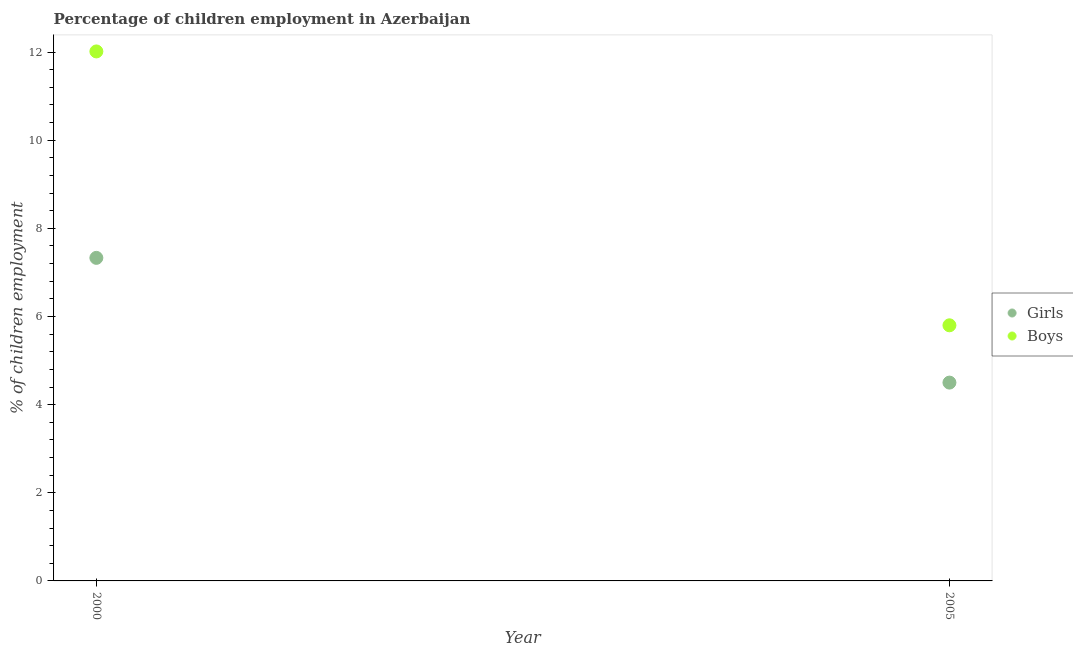What is the percentage of employed boys in 2005?
Ensure brevity in your answer.  5.8. Across all years, what is the maximum percentage of employed boys?
Your answer should be compact. 12.01. Across all years, what is the minimum percentage of employed boys?
Provide a succinct answer. 5.8. What is the total percentage of employed girls in the graph?
Keep it short and to the point. 11.83. What is the difference between the percentage of employed boys in 2000 and that in 2005?
Make the answer very short. 6.21. What is the difference between the percentage of employed boys in 2000 and the percentage of employed girls in 2005?
Provide a short and direct response. 7.51. What is the average percentage of employed boys per year?
Your answer should be very brief. 8.91. In the year 2000, what is the difference between the percentage of employed boys and percentage of employed girls?
Provide a succinct answer. 4.68. In how many years, is the percentage of employed girls greater than 1.6 %?
Offer a very short reply. 2. What is the ratio of the percentage of employed girls in 2000 to that in 2005?
Make the answer very short. 1.63. Is the percentage of employed boys in 2000 less than that in 2005?
Make the answer very short. No. In how many years, is the percentage of employed girls greater than the average percentage of employed girls taken over all years?
Give a very brief answer. 1. Does the percentage of employed girls monotonically increase over the years?
Offer a very short reply. No. Is the percentage of employed boys strictly greater than the percentage of employed girls over the years?
Give a very brief answer. Yes. How many dotlines are there?
Make the answer very short. 2. How many years are there in the graph?
Provide a succinct answer. 2. What is the difference between two consecutive major ticks on the Y-axis?
Your answer should be compact. 2. Does the graph contain any zero values?
Offer a terse response. No. Where does the legend appear in the graph?
Ensure brevity in your answer.  Center right. How many legend labels are there?
Provide a succinct answer. 2. How are the legend labels stacked?
Offer a very short reply. Vertical. What is the title of the graph?
Ensure brevity in your answer.  Percentage of children employment in Azerbaijan. Does "Urban Population" appear as one of the legend labels in the graph?
Your answer should be very brief. No. What is the label or title of the Y-axis?
Your response must be concise. % of children employment. What is the % of children employment of Girls in 2000?
Your answer should be very brief. 7.33. What is the % of children employment of Boys in 2000?
Your answer should be compact. 12.01. What is the % of children employment in Girls in 2005?
Provide a succinct answer. 4.5. What is the % of children employment in Boys in 2005?
Offer a terse response. 5.8. Across all years, what is the maximum % of children employment of Girls?
Keep it short and to the point. 7.33. Across all years, what is the maximum % of children employment of Boys?
Your answer should be very brief. 12.01. Across all years, what is the minimum % of children employment in Girls?
Your response must be concise. 4.5. Across all years, what is the minimum % of children employment in Boys?
Your answer should be very brief. 5.8. What is the total % of children employment of Girls in the graph?
Make the answer very short. 11.83. What is the total % of children employment in Boys in the graph?
Offer a very short reply. 17.81. What is the difference between the % of children employment in Girls in 2000 and that in 2005?
Offer a terse response. 2.83. What is the difference between the % of children employment of Boys in 2000 and that in 2005?
Keep it short and to the point. 6.21. What is the difference between the % of children employment of Girls in 2000 and the % of children employment of Boys in 2005?
Provide a succinct answer. 1.53. What is the average % of children employment in Girls per year?
Offer a terse response. 5.92. What is the average % of children employment in Boys per year?
Your answer should be very brief. 8.91. In the year 2000, what is the difference between the % of children employment of Girls and % of children employment of Boys?
Your response must be concise. -4.68. In the year 2005, what is the difference between the % of children employment of Girls and % of children employment of Boys?
Offer a very short reply. -1.3. What is the ratio of the % of children employment in Girls in 2000 to that in 2005?
Offer a very short reply. 1.63. What is the ratio of the % of children employment of Boys in 2000 to that in 2005?
Provide a succinct answer. 2.07. What is the difference between the highest and the second highest % of children employment in Girls?
Your answer should be very brief. 2.83. What is the difference between the highest and the second highest % of children employment of Boys?
Your response must be concise. 6.21. What is the difference between the highest and the lowest % of children employment in Girls?
Ensure brevity in your answer.  2.83. What is the difference between the highest and the lowest % of children employment in Boys?
Give a very brief answer. 6.21. 